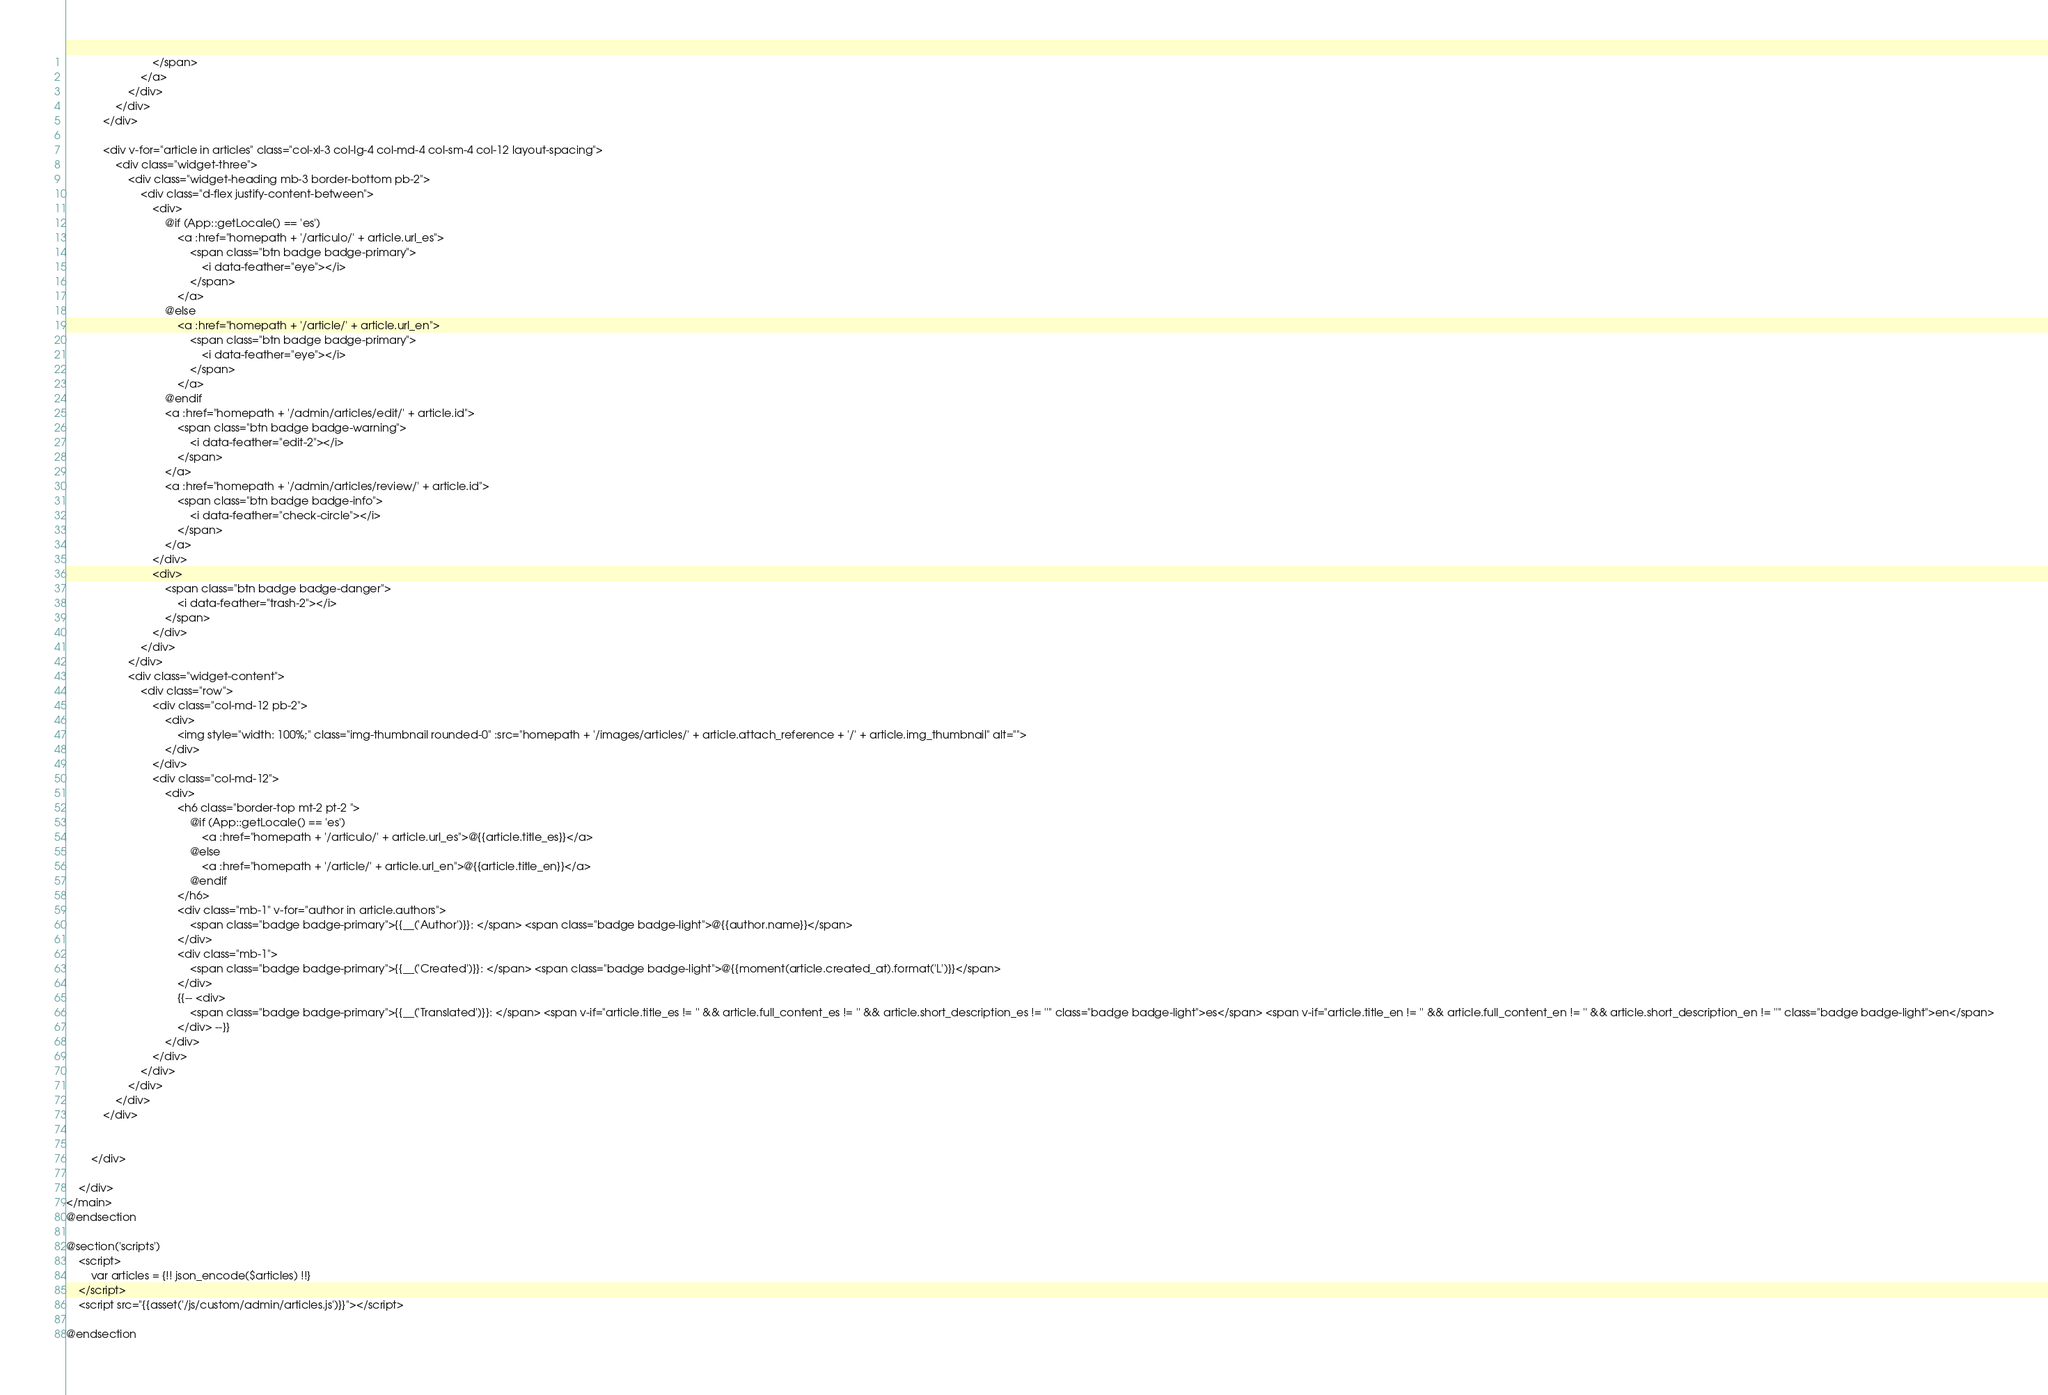Convert code to text. <code><loc_0><loc_0><loc_500><loc_500><_PHP_>                            </span>
                        </a>
                    </div>
                </div>
            </div>
    
            <div v-for="article in articles" class="col-xl-3 col-lg-4 col-md-4 col-sm-4 col-12 layout-spacing">
                <div class="widget-three">
                    <div class="widget-heading mb-3 border-bottom pb-2">
                        <div class="d-flex justify-content-between">
                            <div>
                                @if (App::getLocale() == 'es')
                                    <a :href="homepath + '/articulo/' + article.url_es">
                                        <span class="btn badge badge-primary">
                                            <i data-feather="eye"></i>
                                        </span>
                                    </a>
                                @else
                                    <a :href="homepath + '/article/' + article.url_en">
                                        <span class="btn badge badge-primary">
                                            <i data-feather="eye"></i>
                                        </span>
                                    </a>
                                @endif
                                <a :href="homepath + '/admin/articles/edit/' + article.id">
                                    <span class="btn badge badge-warning">
                                        <i data-feather="edit-2"></i>
                                    </span>
                                </a>
                                <a :href="homepath + '/admin/articles/review/' + article.id">
                                    <span class="btn badge badge-info">
                                        <i data-feather="check-circle"></i>
                                    </span>
                                </a>
                            </div>
                            <div>
                                <span class="btn badge badge-danger">
                                    <i data-feather="trash-2"></i>
                                </span>
                            </div>
                        </div>
                    </div>
                    <div class="widget-content">
                        <div class="row">
                            <div class="col-md-12 pb-2">
                                <div>
                                    <img style="width: 100%;" class="img-thumbnail rounded-0" :src="homepath + '/images/articles/' + article.attach_reference + '/' + article.img_thumbnail" alt="">
                                </div>
                            </div>
                            <div class="col-md-12">
                                <div>
                                    <h6 class="border-top mt-2 pt-2 ">
                                        @if (App::getLocale() == 'es')
                                            <a :href="homepath + '/articulo/' + article.url_es">@{{article.title_es}}</a>
                                        @else
                                            <a :href="homepath + '/article/' + article.url_en">@{{article.title_en}}</a>
                                        @endif
                                    </h6>
                                    <div class="mb-1" v-for="author in article.authors">
                                        <span class="badge badge-primary">{{__('Author')}}: </span> <span class="badge badge-light">@{{author.name}}</span> 
                                    </div>
                                    <div class="mb-1">
                                        <span class="badge badge-primary">{{__('Created')}}: </span> <span class="badge badge-light">@{{moment(article.created_at).format('L')}}</span> 
                                    </div>
                                    {{-- <div>
                                        <span class="badge badge-primary">{{__('Translated')}}: </span> <span v-if="article.title_es != '' && article.full_content_es != '' && article.short_description_es != ''" class="badge badge-light">es</span> <span v-if="article.title_en != '' && article.full_content_en != '' && article.short_description_en != ''" class="badge badge-light">en</span>
                                    </div> --}}
                                </div>
                            </div>
                        </div>
                    </div>
                </div>
            </div>
    
    
        </div>
    
    </div>
</main>
@endsection

@section('scripts')
    <script>
        var articles = {!! json_encode($articles) !!}
    </script>
    <script src="{{asset('/js/custom/admin/articles.js')}}"></script>

@endsection</code> 